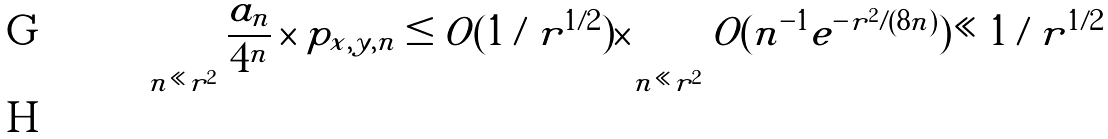<formula> <loc_0><loc_0><loc_500><loc_500>\sum _ { n \ll r ^ { 2 } } \frac { a _ { n } } { 4 ^ { n } } \times p _ { x , y , n } & \leq O ( 1 / r ^ { 1 / 2 } ) \times \sum _ { n \ll r ^ { 2 } } O ( n ^ { - 1 } e ^ { - r ^ { 2 } / ( 8 n ) } ) \ll 1 / r ^ { 1 / 2 } \\</formula> 